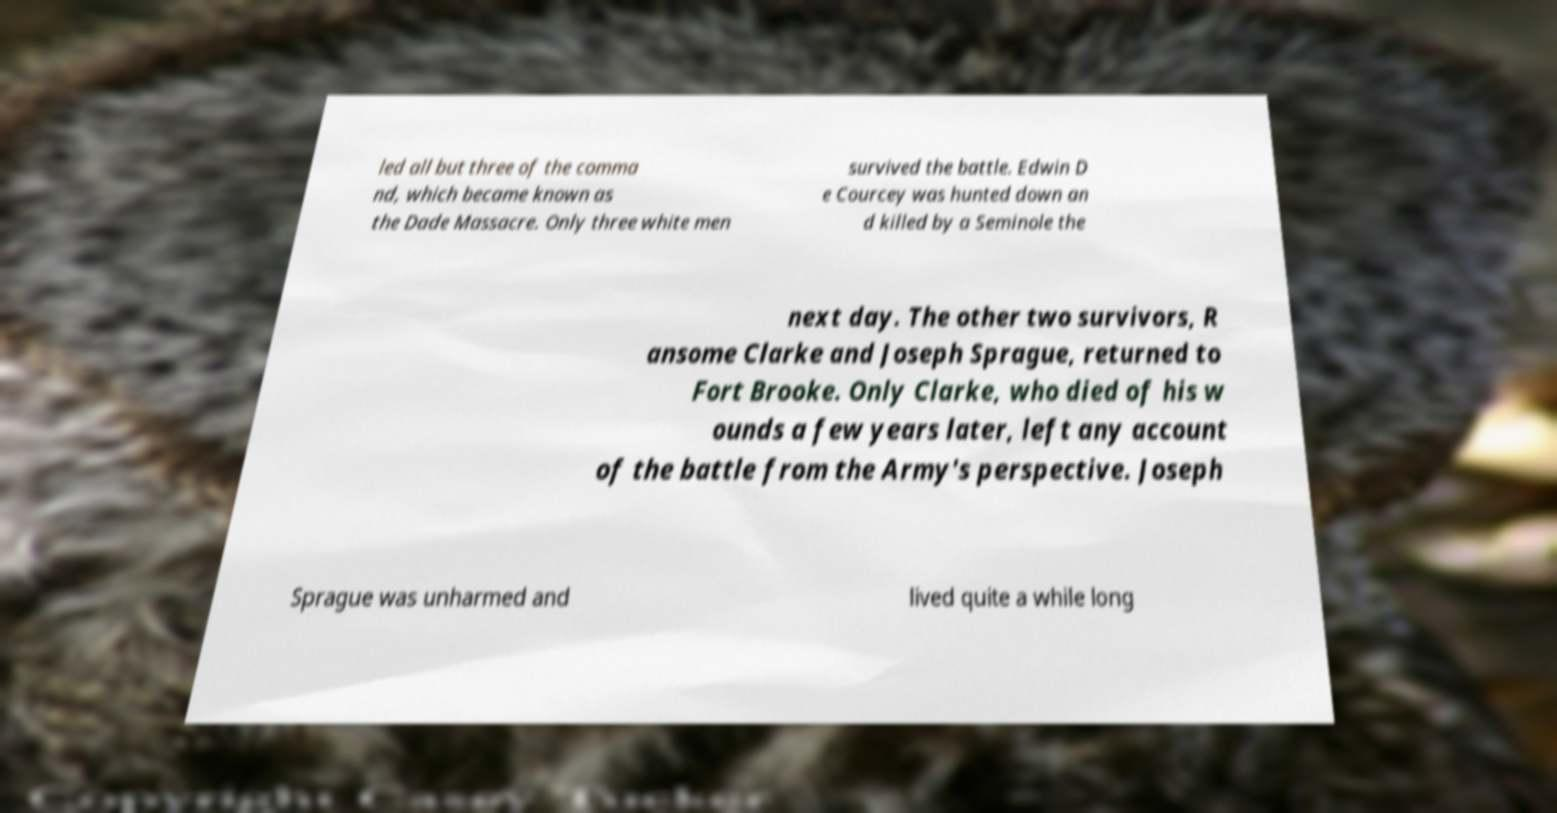What messages or text are displayed in this image? I need them in a readable, typed format. led all but three of the comma nd, which became known as the Dade Massacre. Only three white men survived the battle. Edwin D e Courcey was hunted down an d killed by a Seminole the next day. The other two survivors, R ansome Clarke and Joseph Sprague, returned to Fort Brooke. Only Clarke, who died of his w ounds a few years later, left any account of the battle from the Army's perspective. Joseph Sprague was unharmed and lived quite a while long 